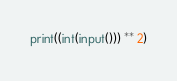<code> <loc_0><loc_0><loc_500><loc_500><_Python_>print((int(input())) ** 2)</code> 